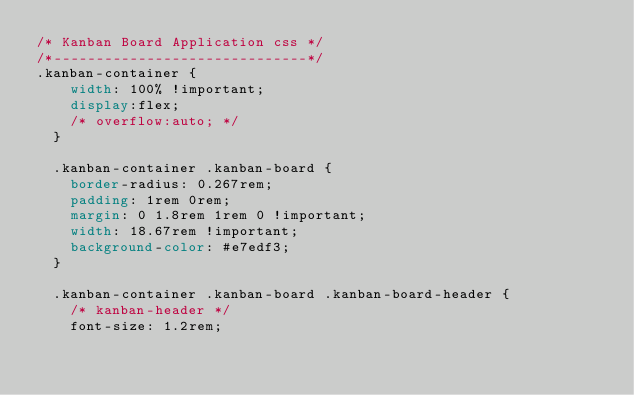Convert code to text. <code><loc_0><loc_0><loc_500><loc_500><_CSS_>/* Kanban Board Application css */
/*------------------------------*/
.kanban-container {
    width: 100% !important;
    display:flex;
    /* overflow:auto; */
  }
  
  .kanban-container .kanban-board {
    border-radius: 0.267rem;
    padding: 1rem 0rem;
    margin: 0 1.8rem 1rem 0 !important;
    width: 18.67rem !important;
    background-color: #e7edf3;
  }
  
  .kanban-container .kanban-board .kanban-board-header {
    /* kanban-header */
    font-size: 1.2rem;</code> 